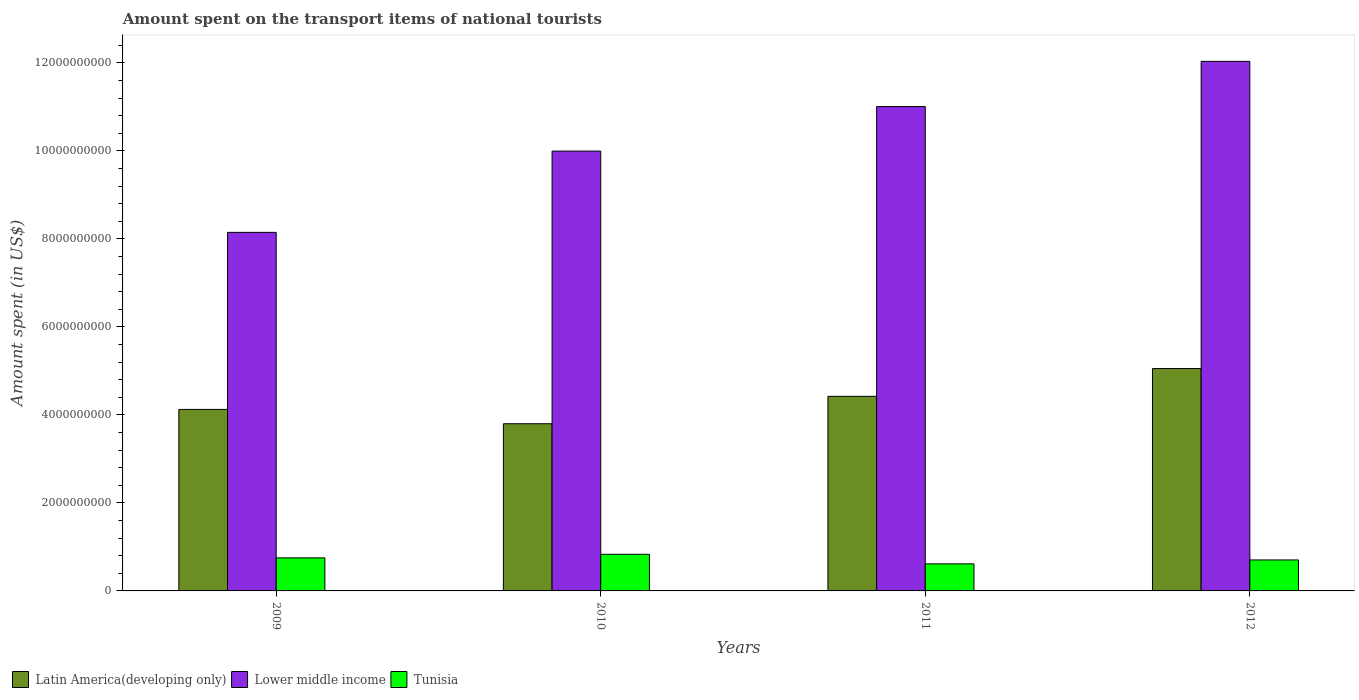How many different coloured bars are there?
Your answer should be very brief. 3. Are the number of bars per tick equal to the number of legend labels?
Your answer should be very brief. Yes. How many bars are there on the 1st tick from the left?
Your answer should be compact. 3. What is the amount spent on the transport items of national tourists in Tunisia in 2009?
Your response must be concise. 7.51e+08. Across all years, what is the maximum amount spent on the transport items of national tourists in Latin America(developing only)?
Your response must be concise. 5.05e+09. Across all years, what is the minimum amount spent on the transport items of national tourists in Tunisia?
Your answer should be compact. 6.15e+08. What is the total amount spent on the transport items of national tourists in Lower middle income in the graph?
Provide a short and direct response. 4.12e+1. What is the difference between the amount spent on the transport items of national tourists in Tunisia in 2009 and that in 2012?
Provide a short and direct response. 4.70e+07. What is the difference between the amount spent on the transport items of national tourists in Tunisia in 2009 and the amount spent on the transport items of national tourists in Lower middle income in 2012?
Provide a short and direct response. -1.13e+1. What is the average amount spent on the transport items of national tourists in Lower middle income per year?
Your answer should be very brief. 1.03e+1. In the year 2011, what is the difference between the amount spent on the transport items of national tourists in Lower middle income and amount spent on the transport items of national tourists in Latin America(developing only)?
Your answer should be compact. 6.59e+09. What is the ratio of the amount spent on the transport items of national tourists in Tunisia in 2009 to that in 2012?
Your answer should be compact. 1.07. Is the amount spent on the transport items of national tourists in Lower middle income in 2009 less than that in 2011?
Provide a succinct answer. Yes. Is the difference between the amount spent on the transport items of national tourists in Lower middle income in 2009 and 2012 greater than the difference between the amount spent on the transport items of national tourists in Latin America(developing only) in 2009 and 2012?
Offer a very short reply. No. What is the difference between the highest and the second highest amount spent on the transport items of national tourists in Lower middle income?
Give a very brief answer. 1.03e+09. What is the difference between the highest and the lowest amount spent on the transport items of national tourists in Tunisia?
Make the answer very short. 2.17e+08. Is the sum of the amount spent on the transport items of national tourists in Latin America(developing only) in 2009 and 2012 greater than the maximum amount spent on the transport items of national tourists in Tunisia across all years?
Your response must be concise. Yes. What does the 1st bar from the left in 2011 represents?
Provide a succinct answer. Latin America(developing only). What does the 2nd bar from the right in 2011 represents?
Your response must be concise. Lower middle income. Are all the bars in the graph horizontal?
Keep it short and to the point. No. Does the graph contain grids?
Offer a very short reply. No. Where does the legend appear in the graph?
Your answer should be compact. Bottom left. What is the title of the graph?
Offer a terse response. Amount spent on the transport items of national tourists. What is the label or title of the Y-axis?
Your answer should be very brief. Amount spent (in US$). What is the Amount spent (in US$) of Latin America(developing only) in 2009?
Provide a succinct answer. 4.13e+09. What is the Amount spent (in US$) of Lower middle income in 2009?
Provide a short and direct response. 8.15e+09. What is the Amount spent (in US$) of Tunisia in 2009?
Ensure brevity in your answer.  7.51e+08. What is the Amount spent (in US$) in Latin America(developing only) in 2010?
Provide a short and direct response. 3.80e+09. What is the Amount spent (in US$) in Lower middle income in 2010?
Keep it short and to the point. 1.00e+1. What is the Amount spent (in US$) of Tunisia in 2010?
Offer a very short reply. 8.32e+08. What is the Amount spent (in US$) of Latin America(developing only) in 2011?
Provide a succinct answer. 4.42e+09. What is the Amount spent (in US$) in Lower middle income in 2011?
Offer a very short reply. 1.10e+1. What is the Amount spent (in US$) of Tunisia in 2011?
Offer a very short reply. 6.15e+08. What is the Amount spent (in US$) of Latin America(developing only) in 2012?
Offer a very short reply. 5.05e+09. What is the Amount spent (in US$) of Lower middle income in 2012?
Offer a terse response. 1.20e+1. What is the Amount spent (in US$) in Tunisia in 2012?
Make the answer very short. 7.04e+08. Across all years, what is the maximum Amount spent (in US$) in Latin America(developing only)?
Give a very brief answer. 5.05e+09. Across all years, what is the maximum Amount spent (in US$) of Lower middle income?
Your response must be concise. 1.20e+1. Across all years, what is the maximum Amount spent (in US$) of Tunisia?
Ensure brevity in your answer.  8.32e+08. Across all years, what is the minimum Amount spent (in US$) of Latin America(developing only)?
Provide a short and direct response. 3.80e+09. Across all years, what is the minimum Amount spent (in US$) in Lower middle income?
Offer a very short reply. 8.15e+09. Across all years, what is the minimum Amount spent (in US$) in Tunisia?
Give a very brief answer. 6.15e+08. What is the total Amount spent (in US$) in Latin America(developing only) in the graph?
Your response must be concise. 1.74e+1. What is the total Amount spent (in US$) of Lower middle income in the graph?
Your answer should be very brief. 4.12e+1. What is the total Amount spent (in US$) of Tunisia in the graph?
Provide a short and direct response. 2.90e+09. What is the difference between the Amount spent (in US$) of Latin America(developing only) in 2009 and that in 2010?
Give a very brief answer. 3.26e+08. What is the difference between the Amount spent (in US$) in Lower middle income in 2009 and that in 2010?
Ensure brevity in your answer.  -1.85e+09. What is the difference between the Amount spent (in US$) of Tunisia in 2009 and that in 2010?
Give a very brief answer. -8.10e+07. What is the difference between the Amount spent (in US$) of Latin America(developing only) in 2009 and that in 2011?
Provide a short and direct response. -2.97e+08. What is the difference between the Amount spent (in US$) in Lower middle income in 2009 and that in 2011?
Your answer should be compact. -2.86e+09. What is the difference between the Amount spent (in US$) of Tunisia in 2009 and that in 2011?
Provide a short and direct response. 1.36e+08. What is the difference between the Amount spent (in US$) of Latin America(developing only) in 2009 and that in 2012?
Make the answer very short. -9.28e+08. What is the difference between the Amount spent (in US$) in Lower middle income in 2009 and that in 2012?
Offer a terse response. -3.89e+09. What is the difference between the Amount spent (in US$) of Tunisia in 2009 and that in 2012?
Make the answer very short. 4.70e+07. What is the difference between the Amount spent (in US$) in Latin America(developing only) in 2010 and that in 2011?
Provide a short and direct response. -6.23e+08. What is the difference between the Amount spent (in US$) of Lower middle income in 2010 and that in 2011?
Provide a short and direct response. -1.01e+09. What is the difference between the Amount spent (in US$) of Tunisia in 2010 and that in 2011?
Ensure brevity in your answer.  2.17e+08. What is the difference between the Amount spent (in US$) of Latin America(developing only) in 2010 and that in 2012?
Give a very brief answer. -1.25e+09. What is the difference between the Amount spent (in US$) in Lower middle income in 2010 and that in 2012?
Your answer should be compact. -2.04e+09. What is the difference between the Amount spent (in US$) in Tunisia in 2010 and that in 2012?
Make the answer very short. 1.28e+08. What is the difference between the Amount spent (in US$) of Latin America(developing only) in 2011 and that in 2012?
Your answer should be very brief. -6.31e+08. What is the difference between the Amount spent (in US$) of Lower middle income in 2011 and that in 2012?
Provide a succinct answer. -1.03e+09. What is the difference between the Amount spent (in US$) of Tunisia in 2011 and that in 2012?
Provide a short and direct response. -8.90e+07. What is the difference between the Amount spent (in US$) of Latin America(developing only) in 2009 and the Amount spent (in US$) of Lower middle income in 2010?
Make the answer very short. -5.87e+09. What is the difference between the Amount spent (in US$) of Latin America(developing only) in 2009 and the Amount spent (in US$) of Tunisia in 2010?
Make the answer very short. 3.29e+09. What is the difference between the Amount spent (in US$) of Lower middle income in 2009 and the Amount spent (in US$) of Tunisia in 2010?
Keep it short and to the point. 7.32e+09. What is the difference between the Amount spent (in US$) in Latin America(developing only) in 2009 and the Amount spent (in US$) in Lower middle income in 2011?
Provide a short and direct response. -6.88e+09. What is the difference between the Amount spent (in US$) in Latin America(developing only) in 2009 and the Amount spent (in US$) in Tunisia in 2011?
Provide a short and direct response. 3.51e+09. What is the difference between the Amount spent (in US$) of Lower middle income in 2009 and the Amount spent (in US$) of Tunisia in 2011?
Ensure brevity in your answer.  7.53e+09. What is the difference between the Amount spent (in US$) in Latin America(developing only) in 2009 and the Amount spent (in US$) in Lower middle income in 2012?
Give a very brief answer. -7.91e+09. What is the difference between the Amount spent (in US$) in Latin America(developing only) in 2009 and the Amount spent (in US$) in Tunisia in 2012?
Provide a succinct answer. 3.42e+09. What is the difference between the Amount spent (in US$) of Lower middle income in 2009 and the Amount spent (in US$) of Tunisia in 2012?
Offer a very short reply. 7.44e+09. What is the difference between the Amount spent (in US$) in Latin America(developing only) in 2010 and the Amount spent (in US$) in Lower middle income in 2011?
Ensure brevity in your answer.  -7.21e+09. What is the difference between the Amount spent (in US$) of Latin America(developing only) in 2010 and the Amount spent (in US$) of Tunisia in 2011?
Keep it short and to the point. 3.18e+09. What is the difference between the Amount spent (in US$) in Lower middle income in 2010 and the Amount spent (in US$) in Tunisia in 2011?
Your answer should be compact. 9.38e+09. What is the difference between the Amount spent (in US$) in Latin America(developing only) in 2010 and the Amount spent (in US$) in Lower middle income in 2012?
Your answer should be compact. -8.24e+09. What is the difference between the Amount spent (in US$) of Latin America(developing only) in 2010 and the Amount spent (in US$) of Tunisia in 2012?
Provide a short and direct response. 3.10e+09. What is the difference between the Amount spent (in US$) in Lower middle income in 2010 and the Amount spent (in US$) in Tunisia in 2012?
Your answer should be compact. 9.29e+09. What is the difference between the Amount spent (in US$) in Latin America(developing only) in 2011 and the Amount spent (in US$) in Lower middle income in 2012?
Offer a very short reply. -7.61e+09. What is the difference between the Amount spent (in US$) in Latin America(developing only) in 2011 and the Amount spent (in US$) in Tunisia in 2012?
Your response must be concise. 3.72e+09. What is the difference between the Amount spent (in US$) in Lower middle income in 2011 and the Amount spent (in US$) in Tunisia in 2012?
Provide a succinct answer. 1.03e+1. What is the average Amount spent (in US$) in Latin America(developing only) per year?
Offer a terse response. 4.35e+09. What is the average Amount spent (in US$) in Lower middle income per year?
Your response must be concise. 1.03e+1. What is the average Amount spent (in US$) of Tunisia per year?
Your answer should be compact. 7.26e+08. In the year 2009, what is the difference between the Amount spent (in US$) of Latin America(developing only) and Amount spent (in US$) of Lower middle income?
Offer a very short reply. -4.02e+09. In the year 2009, what is the difference between the Amount spent (in US$) in Latin America(developing only) and Amount spent (in US$) in Tunisia?
Your response must be concise. 3.37e+09. In the year 2009, what is the difference between the Amount spent (in US$) of Lower middle income and Amount spent (in US$) of Tunisia?
Provide a succinct answer. 7.40e+09. In the year 2010, what is the difference between the Amount spent (in US$) in Latin America(developing only) and Amount spent (in US$) in Lower middle income?
Offer a very short reply. -6.20e+09. In the year 2010, what is the difference between the Amount spent (in US$) of Latin America(developing only) and Amount spent (in US$) of Tunisia?
Your answer should be very brief. 2.97e+09. In the year 2010, what is the difference between the Amount spent (in US$) of Lower middle income and Amount spent (in US$) of Tunisia?
Your response must be concise. 9.16e+09. In the year 2011, what is the difference between the Amount spent (in US$) in Latin America(developing only) and Amount spent (in US$) in Lower middle income?
Offer a terse response. -6.59e+09. In the year 2011, what is the difference between the Amount spent (in US$) of Latin America(developing only) and Amount spent (in US$) of Tunisia?
Provide a succinct answer. 3.81e+09. In the year 2011, what is the difference between the Amount spent (in US$) of Lower middle income and Amount spent (in US$) of Tunisia?
Keep it short and to the point. 1.04e+1. In the year 2012, what is the difference between the Amount spent (in US$) of Latin America(developing only) and Amount spent (in US$) of Lower middle income?
Keep it short and to the point. -6.98e+09. In the year 2012, what is the difference between the Amount spent (in US$) in Latin America(developing only) and Amount spent (in US$) in Tunisia?
Give a very brief answer. 4.35e+09. In the year 2012, what is the difference between the Amount spent (in US$) in Lower middle income and Amount spent (in US$) in Tunisia?
Offer a terse response. 1.13e+1. What is the ratio of the Amount spent (in US$) of Latin America(developing only) in 2009 to that in 2010?
Provide a short and direct response. 1.09. What is the ratio of the Amount spent (in US$) of Lower middle income in 2009 to that in 2010?
Your answer should be very brief. 0.82. What is the ratio of the Amount spent (in US$) in Tunisia in 2009 to that in 2010?
Make the answer very short. 0.9. What is the ratio of the Amount spent (in US$) of Latin America(developing only) in 2009 to that in 2011?
Your answer should be very brief. 0.93. What is the ratio of the Amount spent (in US$) of Lower middle income in 2009 to that in 2011?
Your answer should be very brief. 0.74. What is the ratio of the Amount spent (in US$) in Tunisia in 2009 to that in 2011?
Offer a terse response. 1.22. What is the ratio of the Amount spent (in US$) of Latin America(developing only) in 2009 to that in 2012?
Your response must be concise. 0.82. What is the ratio of the Amount spent (in US$) in Lower middle income in 2009 to that in 2012?
Your response must be concise. 0.68. What is the ratio of the Amount spent (in US$) of Tunisia in 2009 to that in 2012?
Your response must be concise. 1.07. What is the ratio of the Amount spent (in US$) of Latin America(developing only) in 2010 to that in 2011?
Make the answer very short. 0.86. What is the ratio of the Amount spent (in US$) of Lower middle income in 2010 to that in 2011?
Provide a short and direct response. 0.91. What is the ratio of the Amount spent (in US$) in Tunisia in 2010 to that in 2011?
Provide a succinct answer. 1.35. What is the ratio of the Amount spent (in US$) in Latin America(developing only) in 2010 to that in 2012?
Your answer should be very brief. 0.75. What is the ratio of the Amount spent (in US$) of Lower middle income in 2010 to that in 2012?
Offer a very short reply. 0.83. What is the ratio of the Amount spent (in US$) in Tunisia in 2010 to that in 2012?
Keep it short and to the point. 1.18. What is the ratio of the Amount spent (in US$) in Latin America(developing only) in 2011 to that in 2012?
Your answer should be compact. 0.88. What is the ratio of the Amount spent (in US$) in Lower middle income in 2011 to that in 2012?
Give a very brief answer. 0.91. What is the ratio of the Amount spent (in US$) in Tunisia in 2011 to that in 2012?
Make the answer very short. 0.87. What is the difference between the highest and the second highest Amount spent (in US$) in Latin America(developing only)?
Offer a very short reply. 6.31e+08. What is the difference between the highest and the second highest Amount spent (in US$) of Lower middle income?
Ensure brevity in your answer.  1.03e+09. What is the difference between the highest and the second highest Amount spent (in US$) in Tunisia?
Your answer should be compact. 8.10e+07. What is the difference between the highest and the lowest Amount spent (in US$) in Latin America(developing only)?
Offer a terse response. 1.25e+09. What is the difference between the highest and the lowest Amount spent (in US$) in Lower middle income?
Keep it short and to the point. 3.89e+09. What is the difference between the highest and the lowest Amount spent (in US$) of Tunisia?
Offer a terse response. 2.17e+08. 